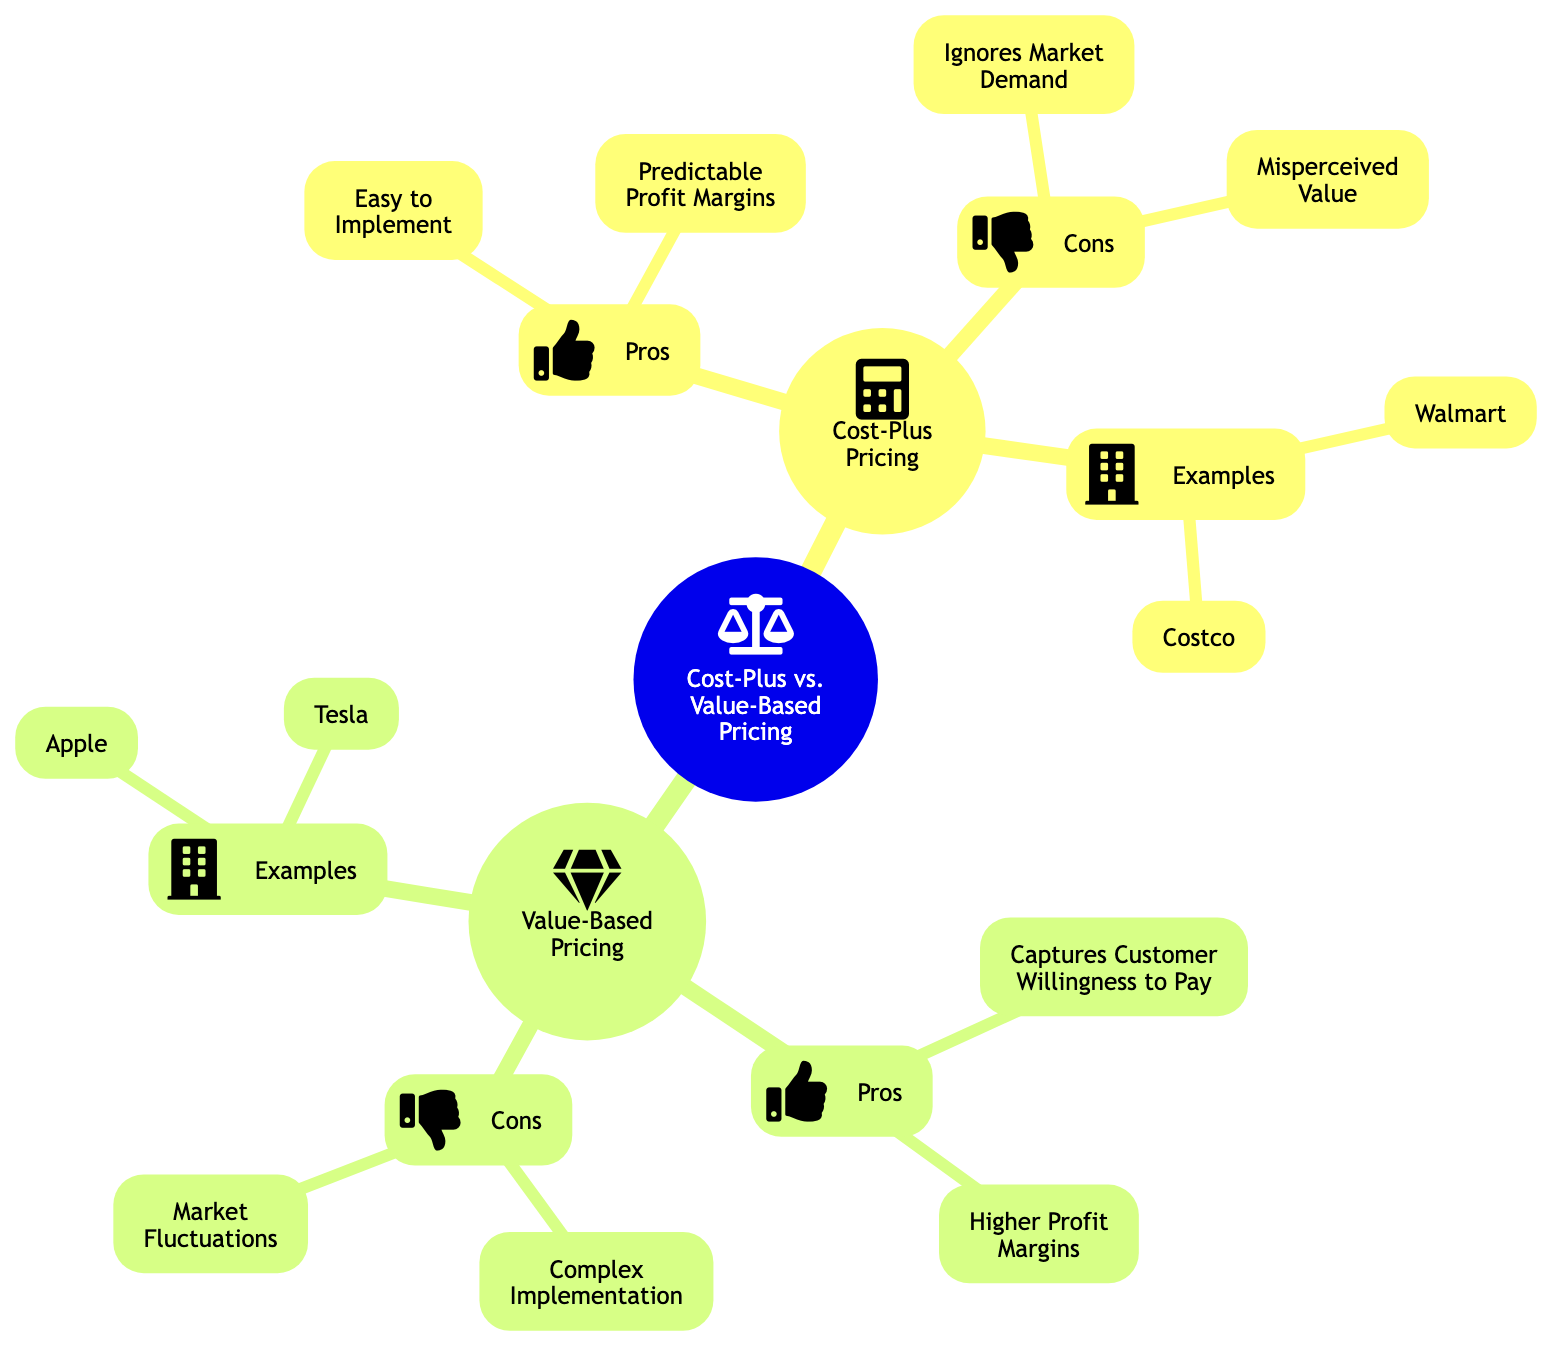What are the two main pricing strategies in the diagram? The diagram identifies two main pricing strategies: Cost-Plus Pricing and Value-Based Pricing. These are highlighted as the primary nodes of the mind map.
Answer: Cost-Plus Pricing, Value-Based Pricing How many pros are listed under Cost-Plus Pricing? Under Cost-Plus Pricing, there are two pros: "Easy to Implement" and "Predictable Profit Margins." This can be counted directly from the diagram's branches.
Answer: 2 What is a con of Value-Based Pricing according to the diagram? The diagram outlines two cons for Value-Based Pricing, one of which is "Complex Implementation." This information is visible in the "Cons" section of the Value-Based Pricing node.
Answer: Complex Implementation Which retail company is associated with premium pricing based on brand loyalty? Within the Real-World Examples section for Value-Based Pricing, "Apple" is noted as using premium pricing based on product innovation and brand loyalty. This direct relationship can be found in the corresponding node.
Answer: Apple What do both pricing strategies fail to account for? Both pricing strategies have their limitations: Cost-Plus Pricing ignores market demand and Value-Based Pricing is sensitive to market fluctuations. These details can be found in the respective "Cons" sections of each pricing strategy.
Answer: Market Demand, Market Fluctuations Which example pays attention to consumer trust with transparent pricing? In the Real-World Examples section under Cost-Plus Pricing, "Costco" is mentioned as using the cost-plus model to earn consumer trust with transparent pricing. This connection is made clear in the node's description.
Answer: Costco How many total companies are listed in the Real-World Examples? The diagram provides four retail companies across both pricing strategies: Walmart and Costco for Cost-Plus Pricing, as well as Apple and Tesla for Value-Based Pricing. Counting these from the examples yields four companies.
Answer: 4 What is one of the reasons why Value-Based Pricing can lead to higher profit margins? Value-Based Pricing can lead to higher profit margins because it "captures customer willingness to pay," which allows businesses to set prices based on perceived value rather than just cost. This is noted in the pros section of the Value-Based Pricing node.
Answer: Captures Customer Willingness to Pay 